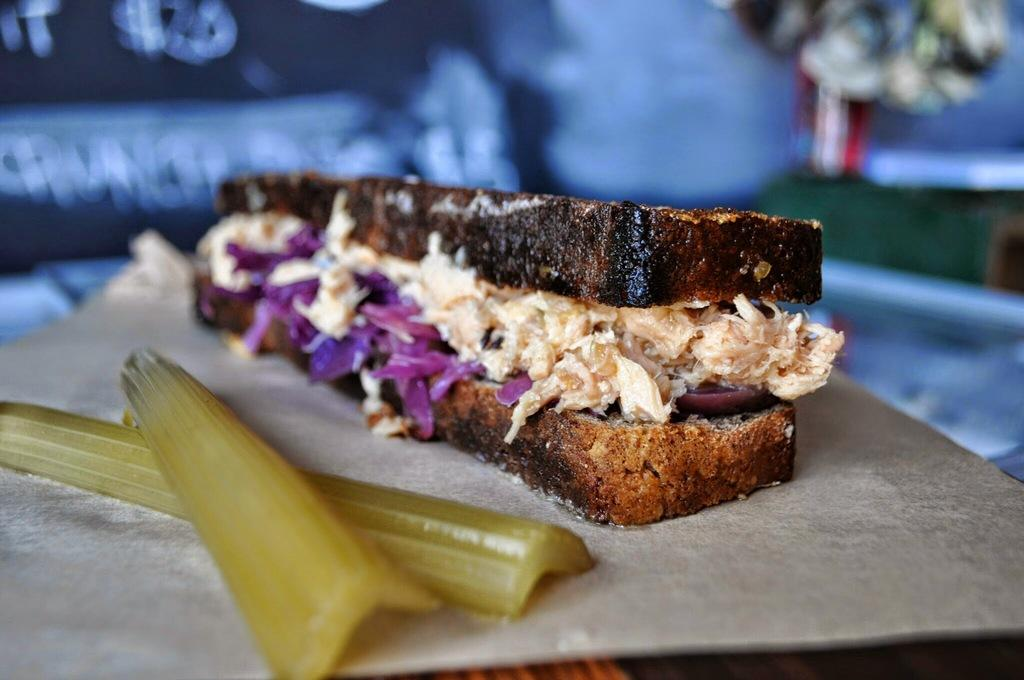What type of food is on the table in the image? There is a sandwich on the table in the image. What is one of the main ingredients of the sandwich? There is bread on the table, which is a main ingredient of the sandwich. What other items can be seen on the table? There are vegetables on the table. What is located in the top right corner of the image? There is a flower pot in the top right corner of the image. What can be seen hanging or displayed in the image? There is a banner visible in the image. Can you see a hose spraying water on the vegetables in the image? There is no hose or water spray visible in the image; it only shows a sandwich, bread, vegetables, a flower pot, and a banner. 